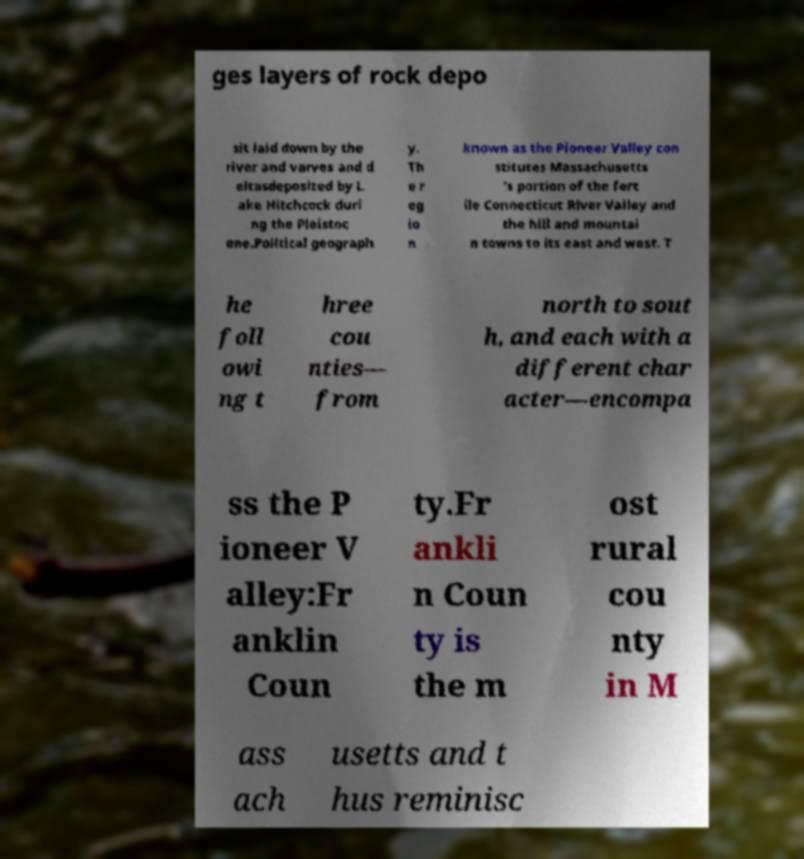Could you extract and type out the text from this image? ges layers of rock depo sit laid down by the river and varves and d eltasdeposited by L ake Hitchcock duri ng the Pleistoc ene.Political geograph y. Th e r eg io n known as the Pioneer Valley con stitutes Massachusetts 's portion of the fert ile Connecticut River Valley and the hill and mountai n towns to its east and west. T he foll owi ng t hree cou nties— from north to sout h, and each with a different char acter—encompa ss the P ioneer V alley:Fr anklin Coun ty.Fr ankli n Coun ty is the m ost rural cou nty in M ass ach usetts and t hus reminisc 